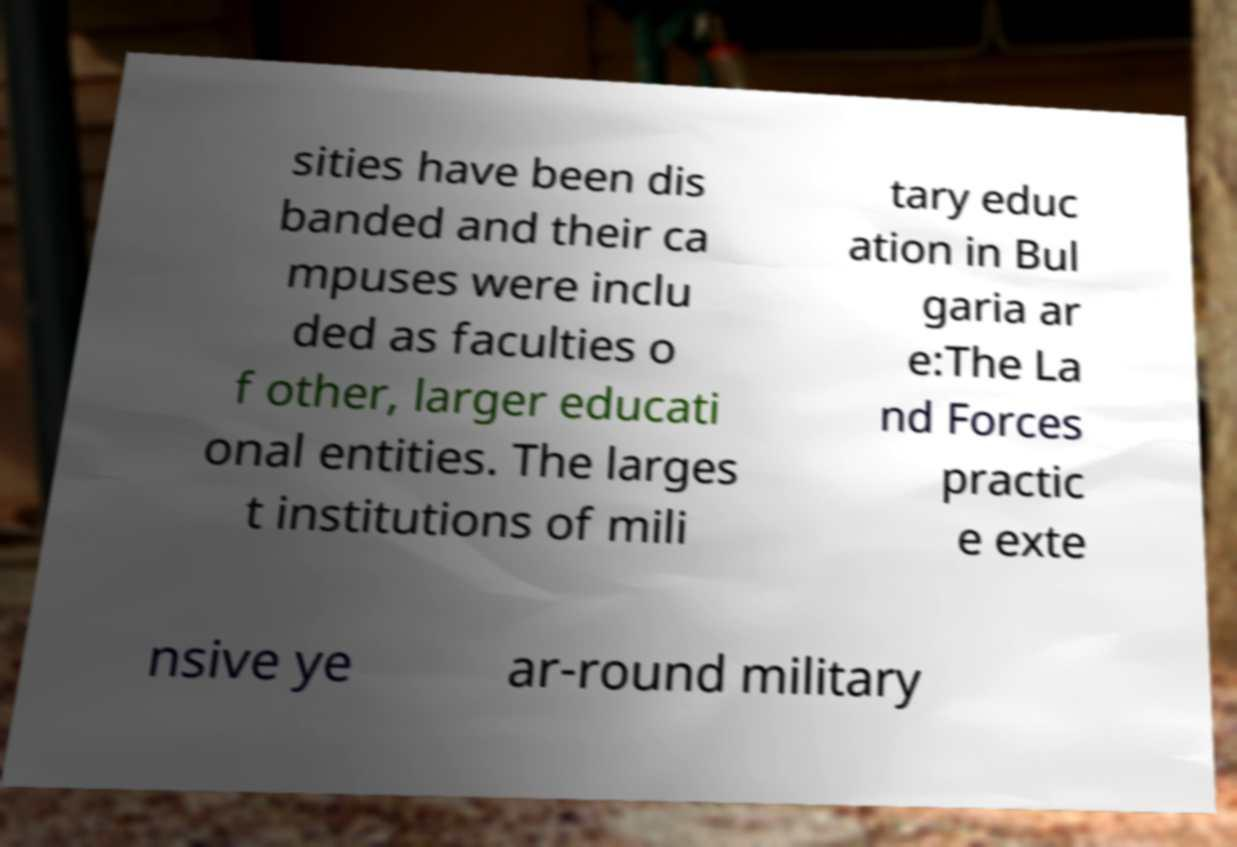Could you assist in decoding the text presented in this image and type it out clearly? sities have been dis banded and their ca mpuses were inclu ded as faculties o f other, larger educati onal entities. The larges t institutions of mili tary educ ation in Bul garia ar e:The La nd Forces practic e exte nsive ye ar-round military 